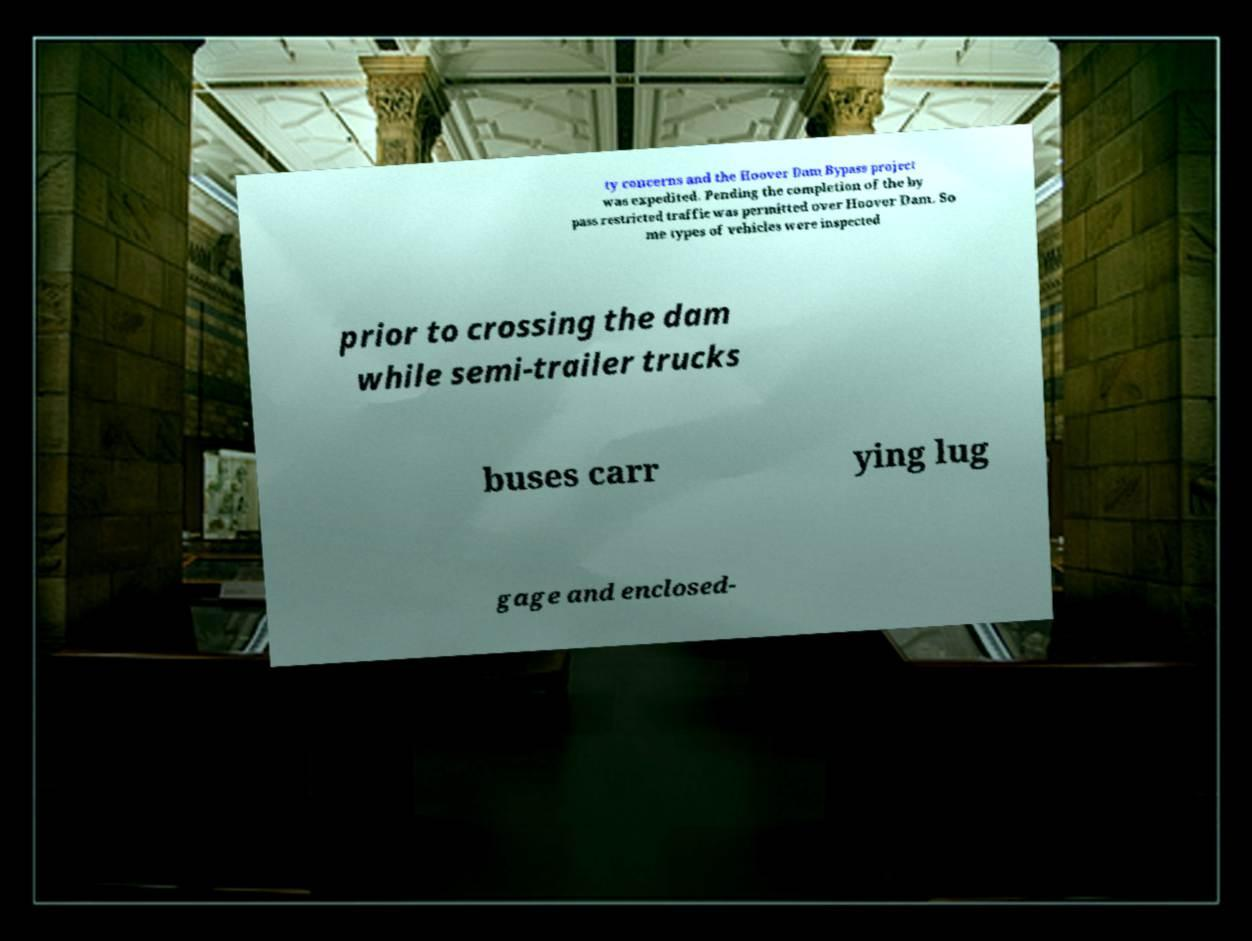I need the written content from this picture converted into text. Can you do that? ty concerns and the Hoover Dam Bypass project was expedited. Pending the completion of the by pass restricted traffic was permitted over Hoover Dam. So me types of vehicles were inspected prior to crossing the dam while semi-trailer trucks buses carr ying lug gage and enclosed- 